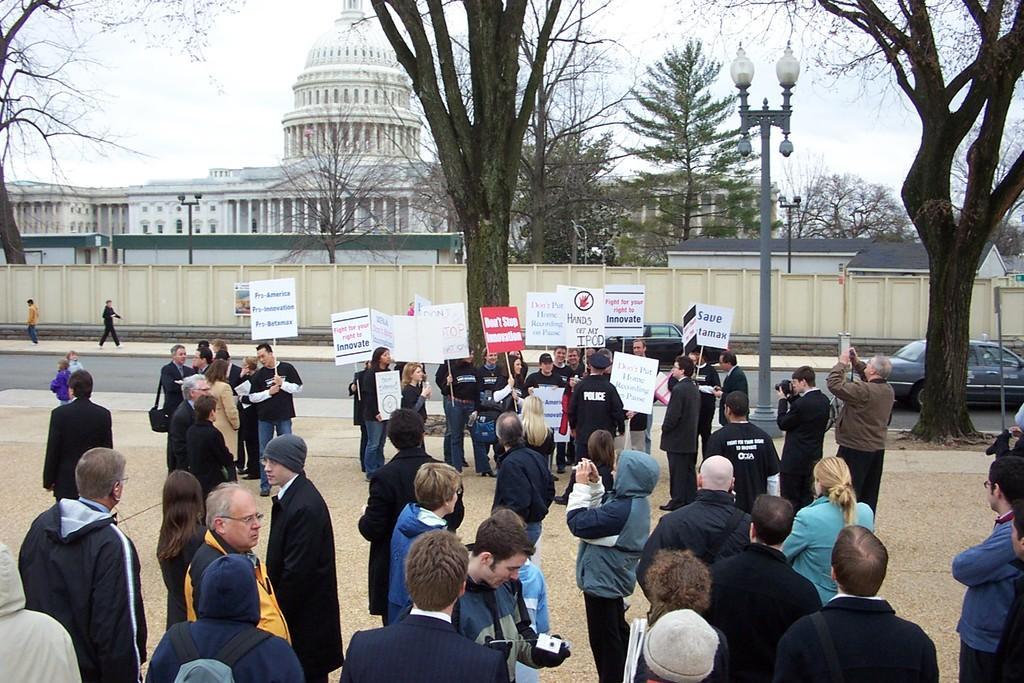Could you give a brief overview of what you see in this image? In this image, there are a few people. Among them, we can see some people holding objects. There are a few buildings, vehicles, trees and poles. We can see some boards with text and images. We can also see the wall and the sky. 